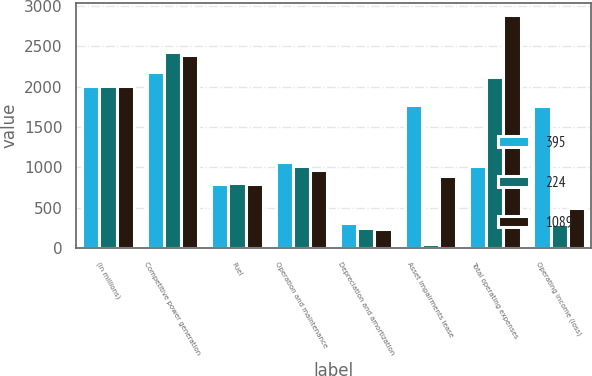Convert chart to OTSL. <chart><loc_0><loc_0><loc_500><loc_500><stacked_bar_chart><ecel><fcel>(in millions)<fcel>Competitive power generation<fcel>Fuel<fcel>Operation and maintenance<fcel>Depreciation and amortization<fcel>Asset impairments lease<fcel>Total operating expenses<fcel>Operating income (loss)<nl><fcel>395<fcel>2011<fcel>2186<fcel>799<fcel>1069<fcel>310<fcel>1772<fcel>1020<fcel>1764<nl><fcel>224<fcel>2010<fcel>2429<fcel>809<fcel>1020<fcel>249<fcel>48<fcel>2126<fcel>303<nl><fcel>1089<fcel>2009<fcel>2399<fcel>796<fcel>964<fcel>239<fcel>891<fcel>2890<fcel>491<nl></chart> 